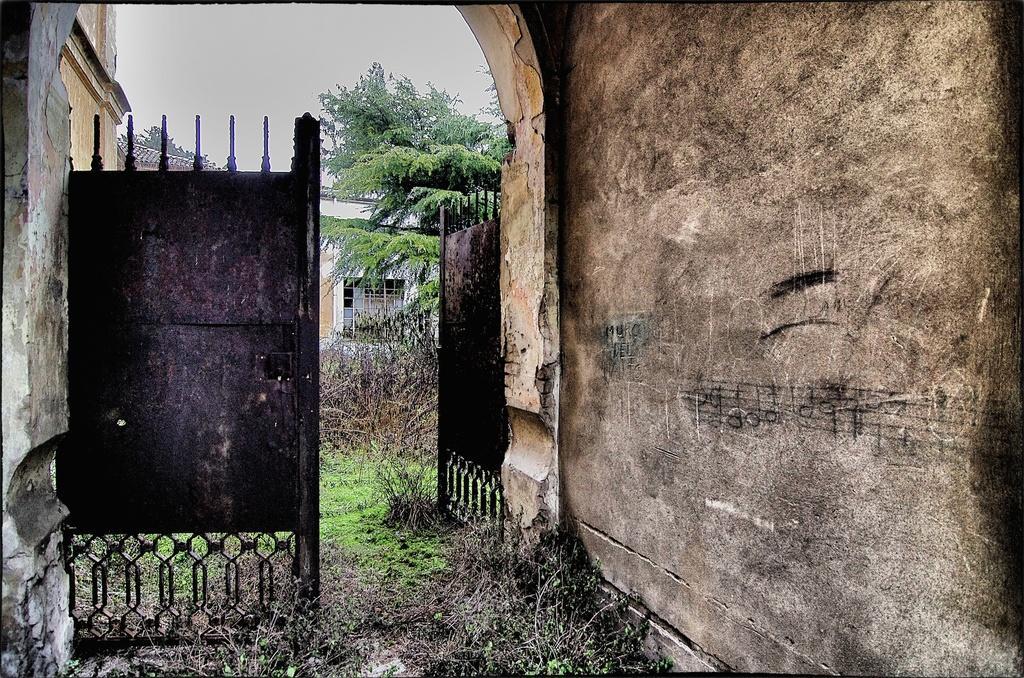Describe this image in one or two sentences. In this image we can see a gate and the walls. We can also see some plants, grass, trees, a building with windows and the sky which looks cloudy. 